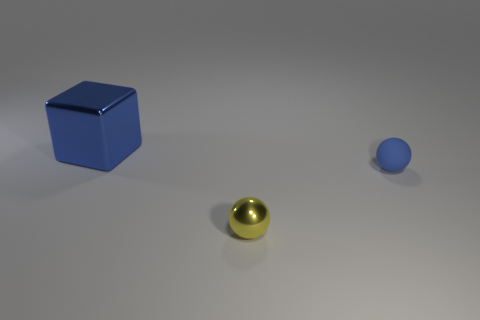Are there any other things that have the same size as the blue shiny cube?
Your response must be concise. No. There is a yellow object that is the same material as the large block; what is its size?
Ensure brevity in your answer.  Small. Are there any metal cubes of the same color as the big object?
Keep it short and to the point. No. Does the blue rubber sphere have the same size as the blue object that is to the left of the matte sphere?
Provide a short and direct response. No. There is a object that is right of the metal object that is in front of the cube; how many tiny blue balls are to the right of it?
Your response must be concise. 0. The rubber sphere that is the same color as the big object is what size?
Offer a terse response. Small. There is a yellow sphere; are there any tiny shiny things in front of it?
Offer a terse response. No. The large metal thing has what shape?
Offer a very short reply. Cube. What shape is the shiny thing that is in front of the blue thing that is in front of the object left of the small yellow sphere?
Offer a very short reply. Sphere. What number of other objects are the same shape as the tiny blue object?
Provide a short and direct response. 1. 